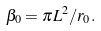<formula> <loc_0><loc_0><loc_500><loc_500>\beta _ { 0 } = \pi L ^ { 2 } / r _ { 0 } .</formula> 